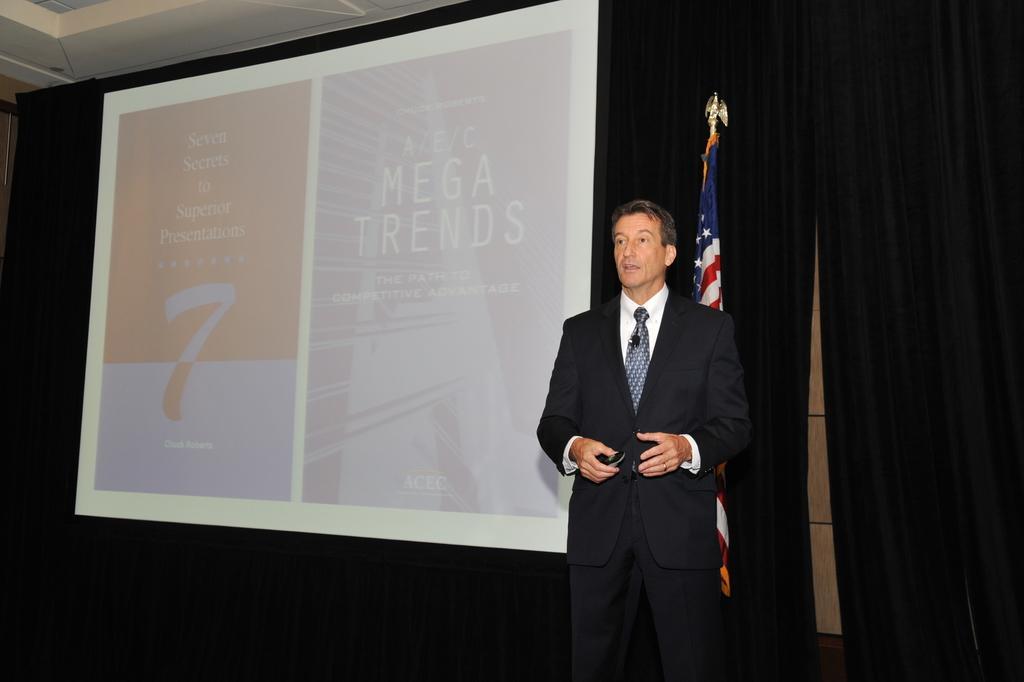How would you summarize this image in a sentence or two? In this picture we can see a man wearing a blazer, tie and holding a device with his hand and standing and at the back of him we can see a flag, screen and curtains. 